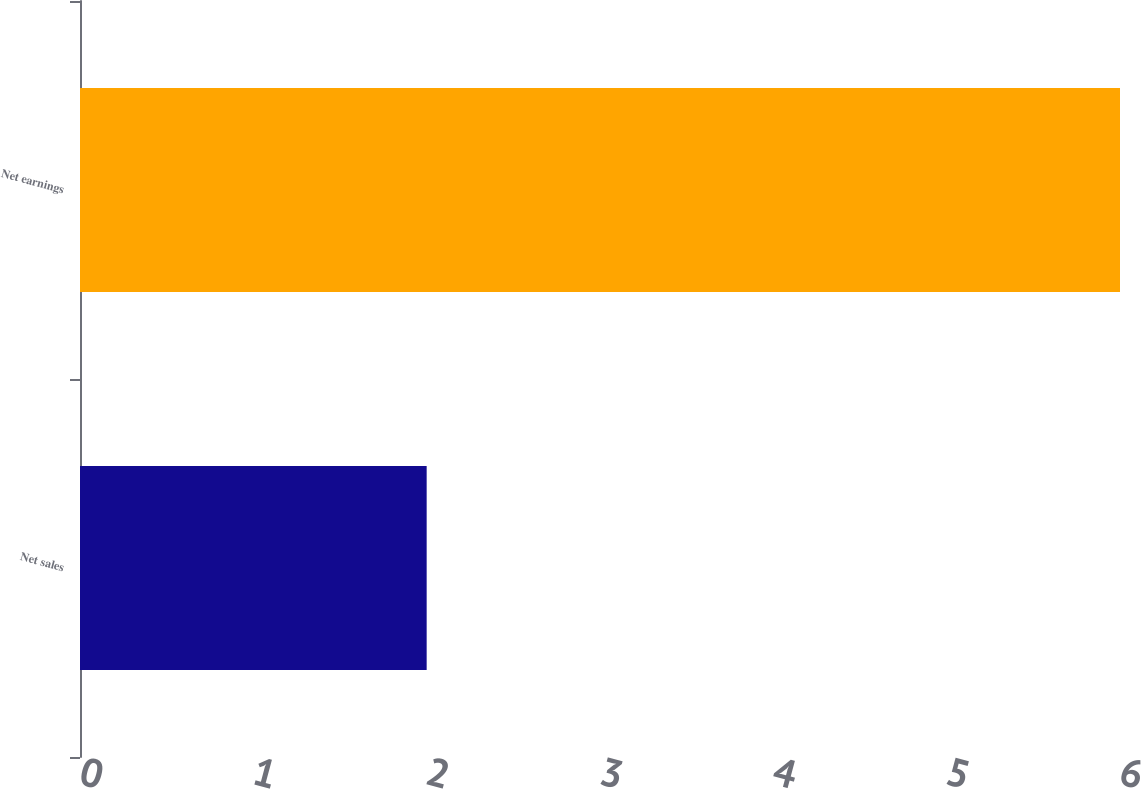Convert chart to OTSL. <chart><loc_0><loc_0><loc_500><loc_500><bar_chart><fcel>Net sales<fcel>Net earnings<nl><fcel>2<fcel>6<nl></chart> 